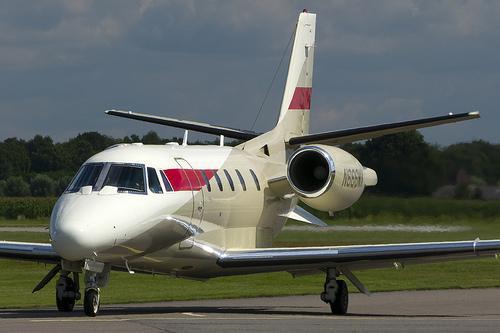How many planes are there?
Give a very brief answer. 1. 